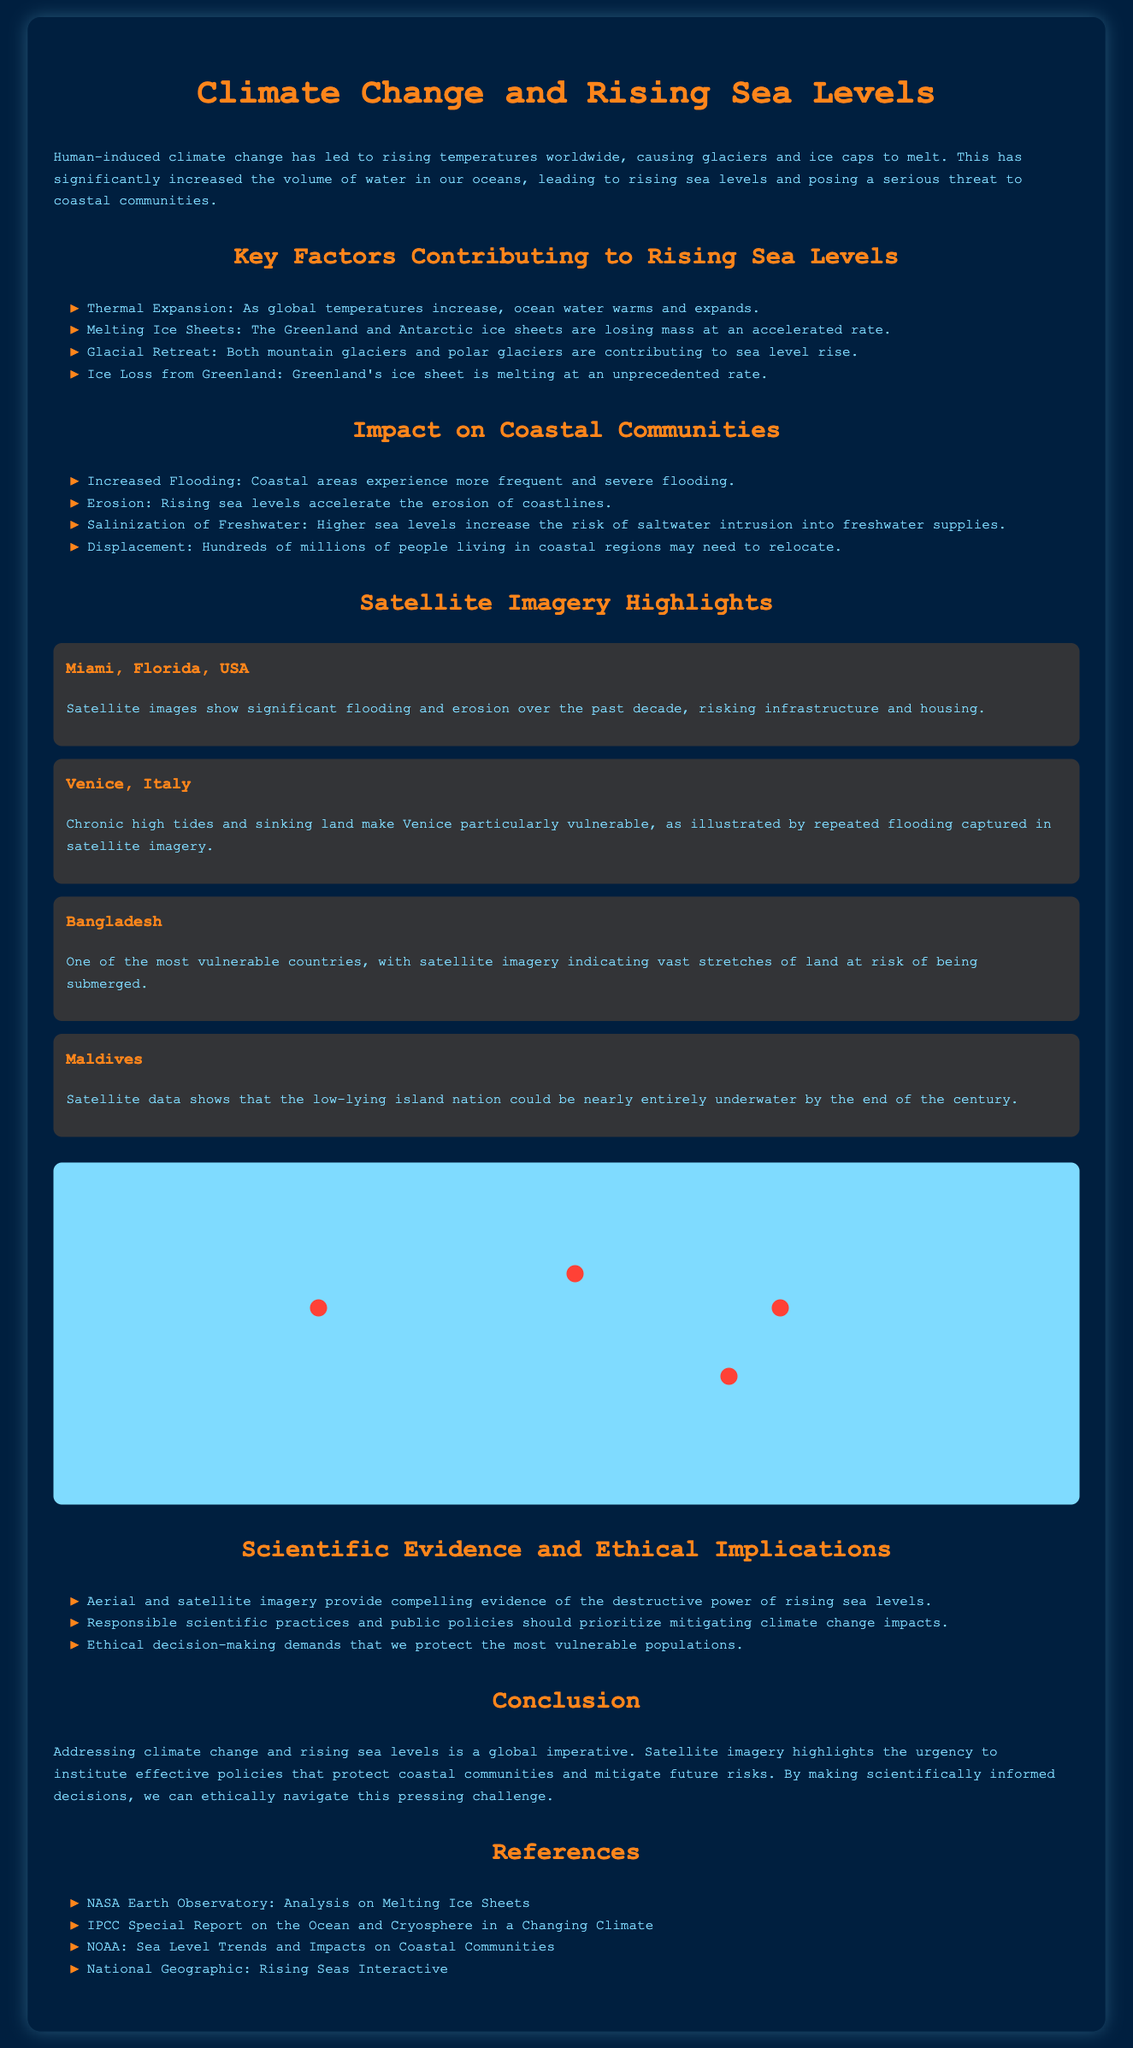what are the key factors contributing to rising sea levels? The key factors include thermal expansion, melting ice sheets, glacial retreat, and ice loss from Greenland.
Answer: thermal expansion, melting ice sheets, glacial retreat, ice loss from Greenland which satellite imagery highlights the risk to Miami? Satellite images show significant flooding and erosion over the past decade, risking infrastructure and housing.
Answer: flooding and erosion what is the potential future risk for the Maldives? Satellite data shows that the low-lying island nation could be nearly entirely underwater by the end of the century.
Answer: nearly entirely underwater how do rising sea levels affect freshwater supplies? Higher sea levels increase the risk of saltwater intrusion into freshwater supplies.
Answer: saltwater intrusion which coastal community is particularly vulnerable to chronic high tides? Venice is particularly vulnerable due to chronic high tides and sinking land.
Answer: Venice what do scientific practices prioritize according to the document? Responsible scientific practices and public policies should prioritize mitigating climate change impacts.
Answer: mitigating climate change impacts what is the document type? The document is a geographic infographic focusing on climate change and rising sea levels.
Answer: geographic infographic how many regions are highlighted with satellite imagery? Four regions are highlighted: Miami, Venice, Bangladesh, and Maldives.
Answer: four regions 